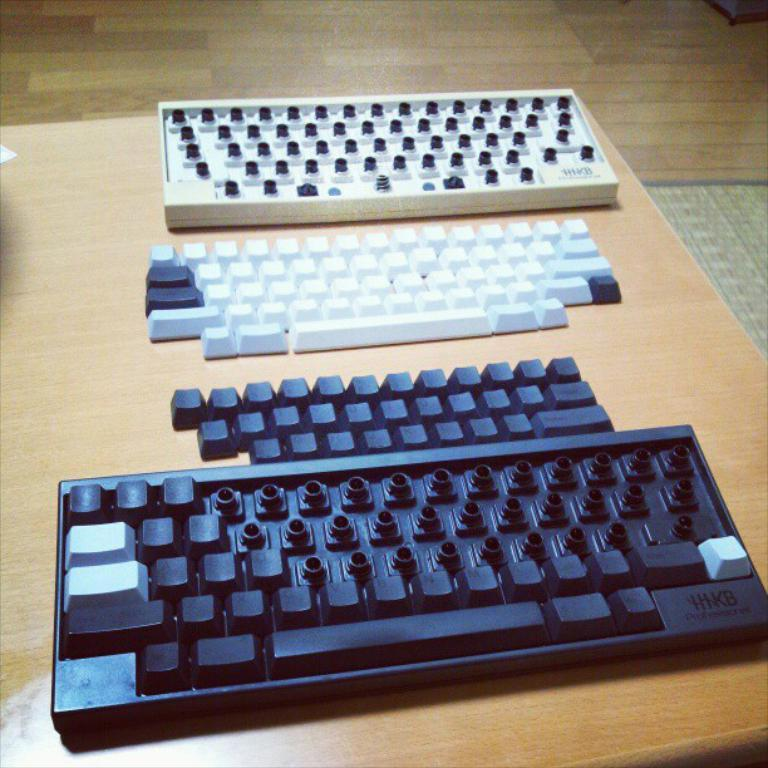<image>
Summarize the visual content of the image. two HIKB keyboards taken apart on a table 